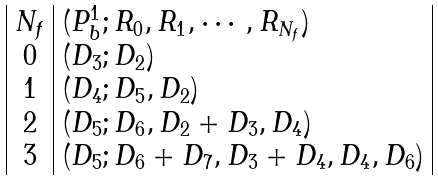Convert formula to latex. <formula><loc_0><loc_0><loc_500><loc_500>\begin{array} { | c | l | } N _ { f } & ( { P } ^ { 1 } _ { b } ; R _ { 0 } , R _ { 1 } , \cdots , R _ { N _ { f } } ) \\ 0 & ( D _ { 3 } ; D _ { 2 } ) \\ 1 & ( D _ { 4 } ; D _ { 5 } , D _ { 2 } ) \\ 2 & ( D _ { 5 } ; D _ { 6 } , D _ { 2 } + D _ { 3 } , D _ { 4 } ) \\ 3 & ( D _ { 5 } ; D _ { 6 } + D _ { 7 } , D _ { 3 } + D _ { 4 } , D _ { 4 } , D _ { 6 } ) \\ \end{array}</formula> 